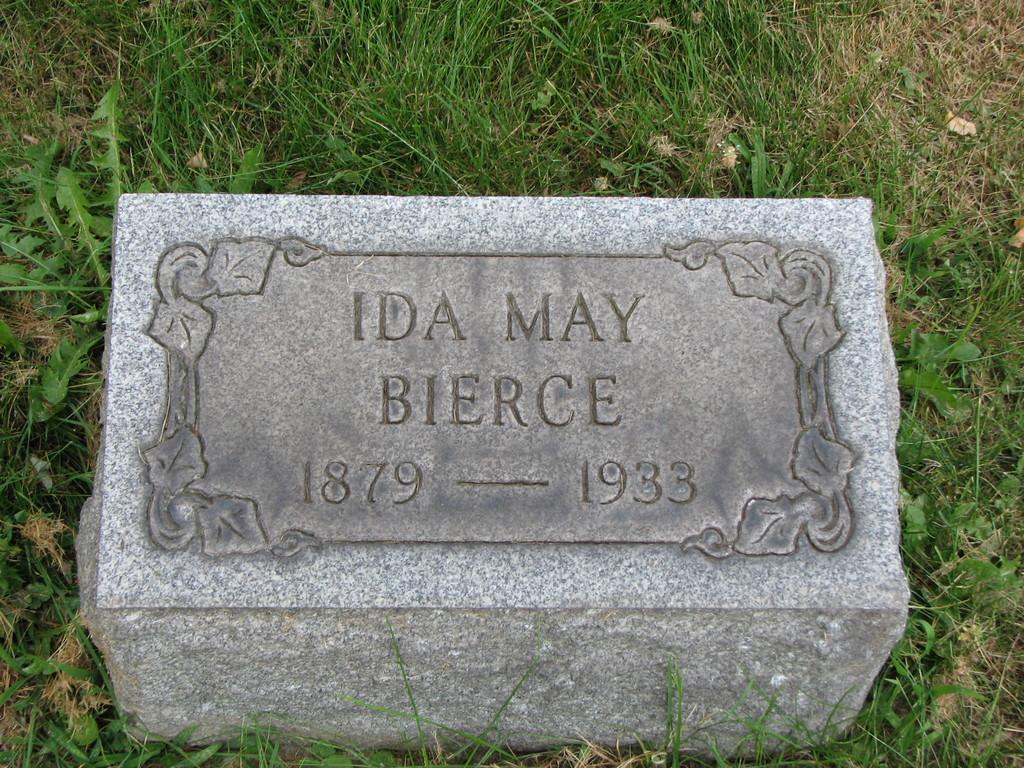Can you describe this image briefly? In this picture we can see a stone on the grass. 